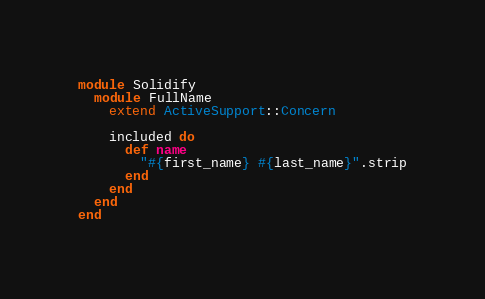<code> <loc_0><loc_0><loc_500><loc_500><_Ruby_>module Solidify
  module FullName
    extend ActiveSupport::Concern

    included do
      def name
        "#{first_name} #{last_name}".strip
      end
    end
  end
end
</code> 